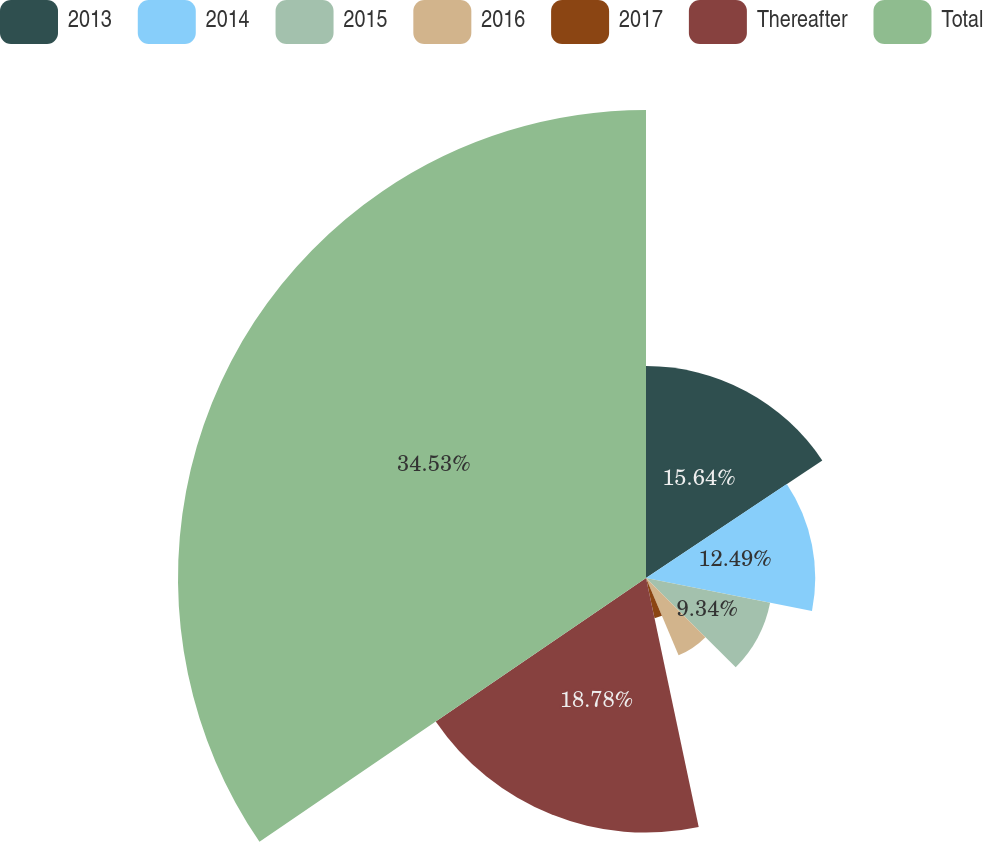Convert chart. <chart><loc_0><loc_0><loc_500><loc_500><pie_chart><fcel>2013<fcel>2014<fcel>2015<fcel>2016<fcel>2017<fcel>Thereafter<fcel>Total<nl><fcel>15.64%<fcel>12.49%<fcel>9.34%<fcel>6.19%<fcel>3.03%<fcel>18.79%<fcel>34.54%<nl></chart> 